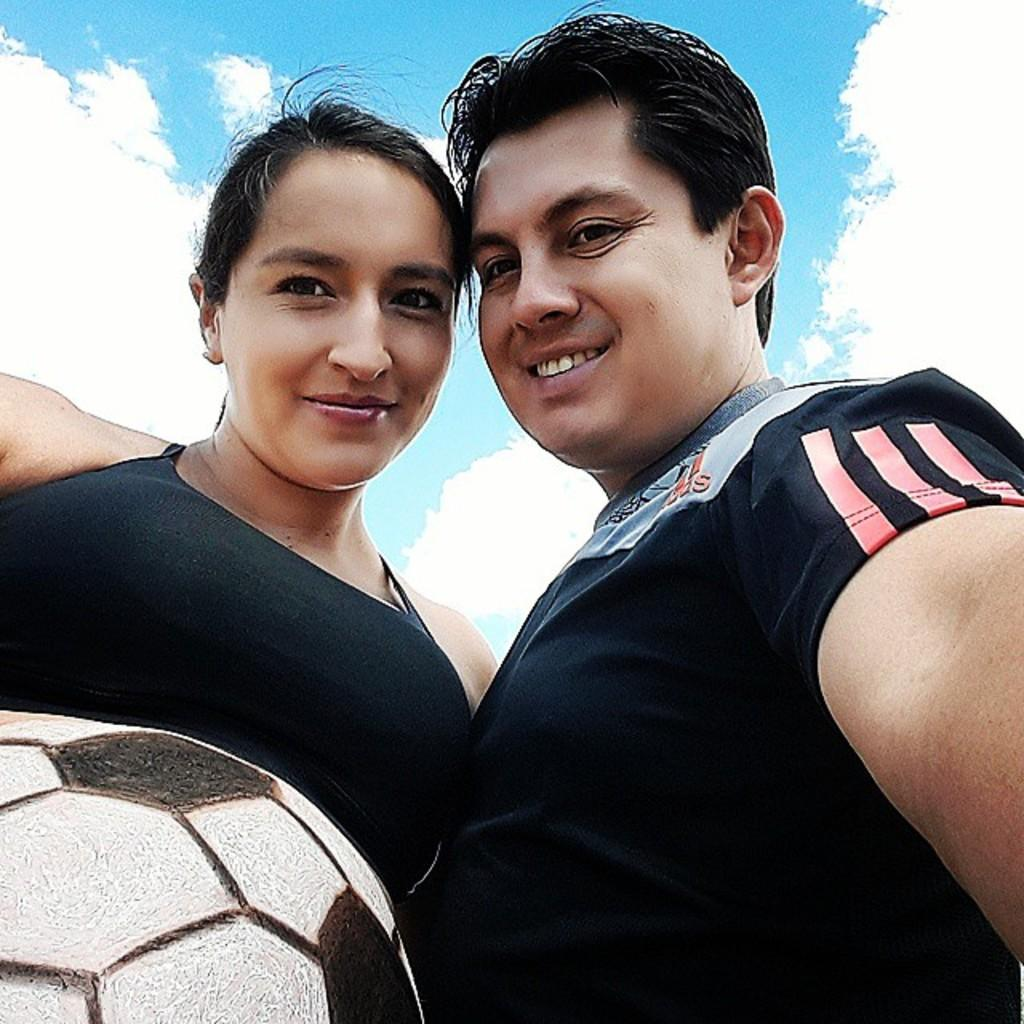How many people are present in the image? There are two persons in the image. What object can be seen in the image besides the people? There is a ball in the image. Is there a river flowing through the image? No, there is no river present in the image. What type of farm can be seen in the background of the image? There is no farm visible in the image. 